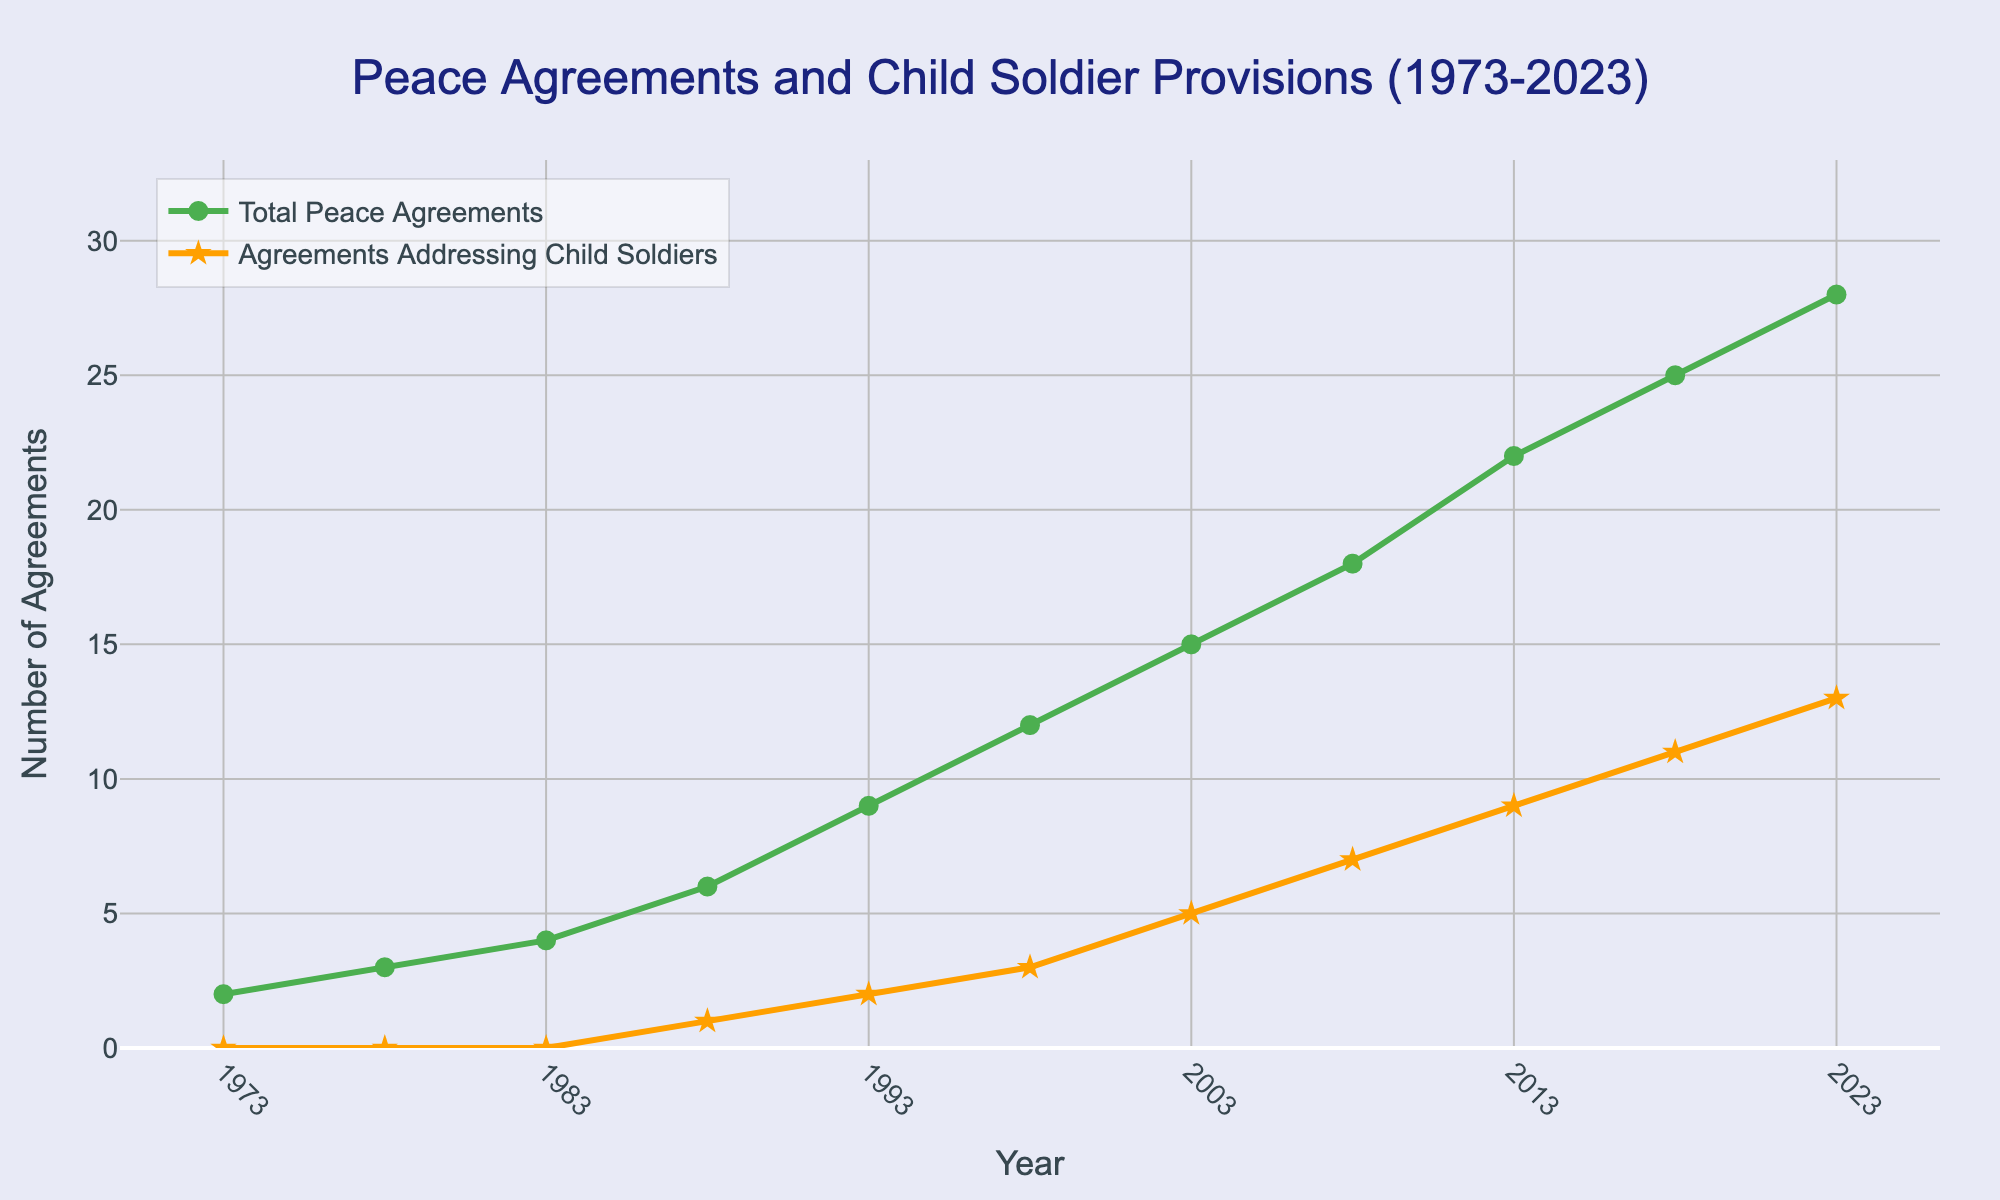Which year saw the highest number of total peace agreements signed? From the plot, you can see that the highest number of total peace agreements signed is 28. The corresponding year on the x-axis for this value is 2023.
Answer: 2023 How many peace agreements addressed child soldiers in 2013? Looking at the year 2013 on the x-axis, and then checking the value for the orange line corresponding to "Agreements Addressing Child Soldiers," we observe that it is 9.
Answer: 9 What is the difference between the total number of peace agreements signed in 1988 and 2008? The number of total peace agreements in 1988 is 6, and in 2008 it is 18. The difference is 18 - 6 = 12.
Answer: 12 In which year was the proportion of agreements addressing child soldiers to total peace agreements the highest? To find this, calculate the proportion for each year and compare. For example, in 2023, the proportion is 13/28, which is approximately 0.464. Comparing all the years, we find that 2023 has the highest proportion.
Answer: 2023 Between 1988 and 1993, by how much did the total number of peace agreements increase? The number of total peace agreements in 1988 is 6 and in 1993 it is 9. The increase is 9 - 6 = 3.
Answer: 3 Which line represents agreements addressing child soldiers? There are two lines on the graph. The orange line with star markers represents "Agreements Addressing Child Soldiers."
Answer: Orange line with star markers By how many did the number of agreements addressing child soldiers increase between 2008 and 2023? The number of agreements addressing child soldiers in 2008 is 7, and in 2023 it is 13. The increase is 13 - 7 = 6.
Answer: 6 What trend is observed in the number of total peace agreements over the last 50 years? The green line representing total peace agreements shows a continuous upward trend, indicating an increase over the last 50 years.
Answer: Upward trend Which year had the first peace agreement addressing child soldiers? The first non-zero value for the "Agreements Addressing Child Soldiers" line is at the year 1988.
Answer: 1988 